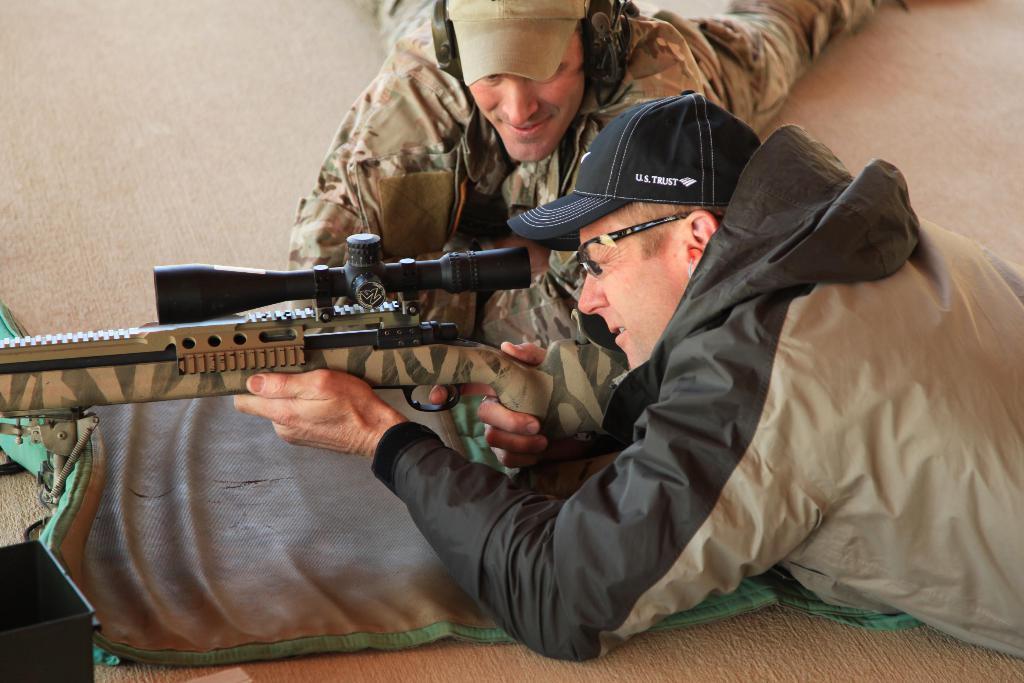Please provide a concise description of this image. This image consists of two persons lying on the ground. In the front, the man wearing a black cap is holding a gun. In the background, the man wearing brown cap is also wearing a headset. At the bottom, there is a mat on the floor. 